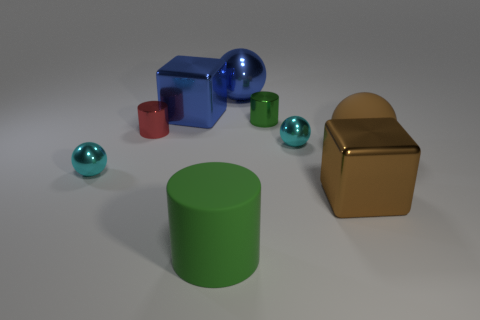Subtract all cylinders. How many objects are left? 6 Subtract all large cylinders. Subtract all green metal things. How many objects are left? 7 Add 3 cylinders. How many cylinders are left? 6 Add 2 green objects. How many green objects exist? 4 Subtract 0 gray balls. How many objects are left? 9 